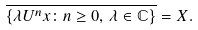<formula> <loc_0><loc_0><loc_500><loc_500>\overline { \left \{ \lambda U ^ { n } x \colon n \geq 0 , \, \lambda \in \mathbb { C } \right \} } = X .</formula> 